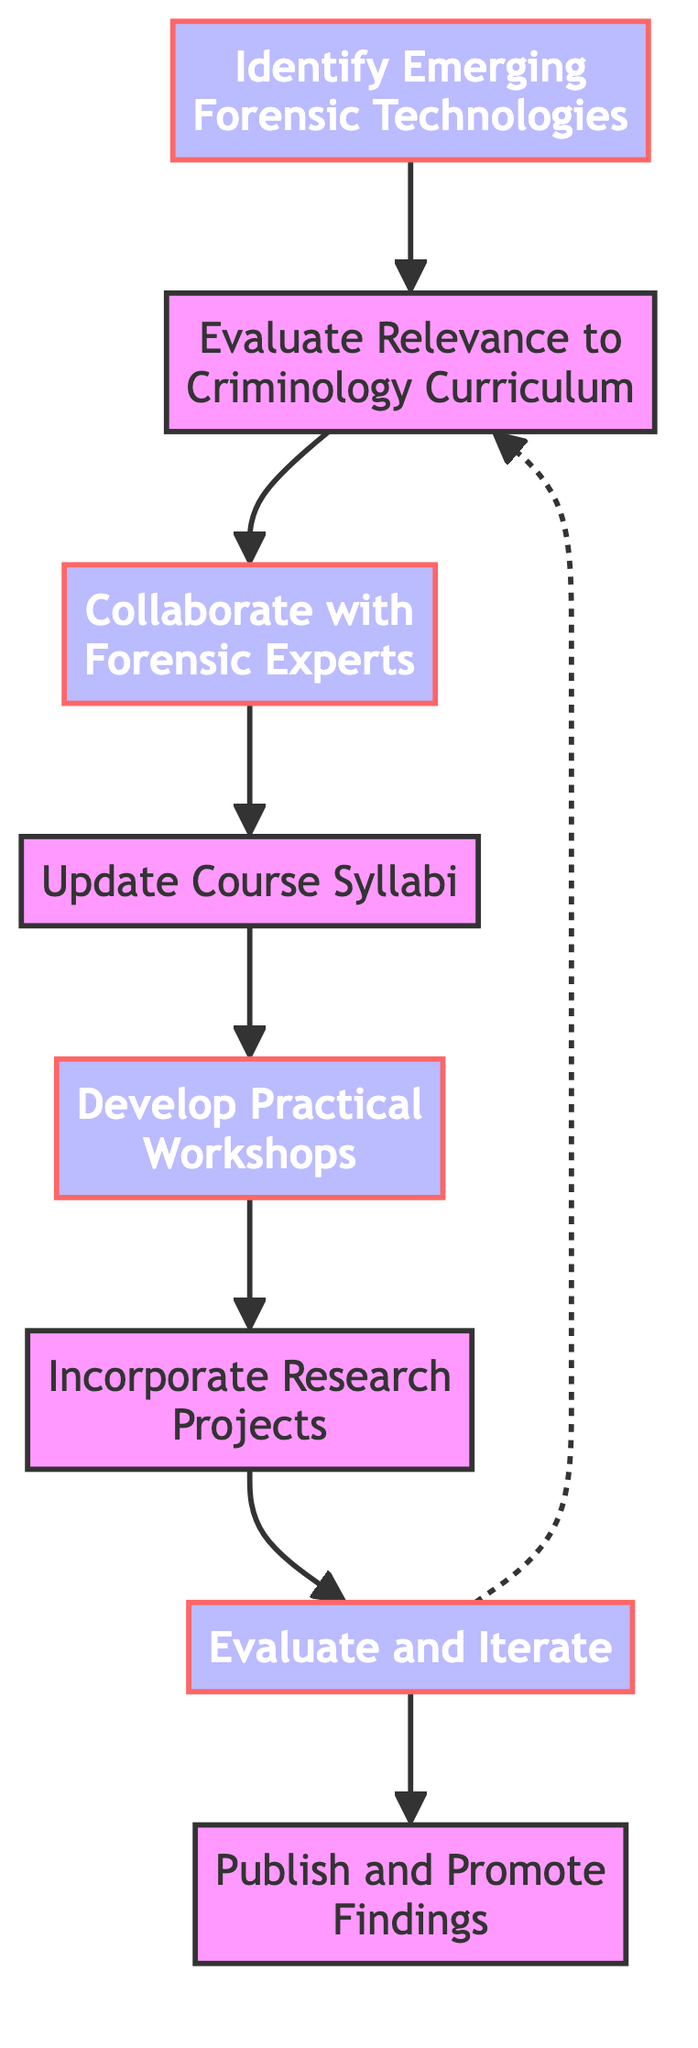What is the first step in the integration of new forensic technology? The first step shown in the diagram is "Identify Emerging Forensic Technologies," indicating that the process begins with surveying advancements in forensic science.
Answer: Identify Emerging Forensic Technologies How many main nodes are present in the diagram? The diagram features eight main nodes, representing distinct steps in the process of integrating new forensic technologies.
Answer: 8 Which step follows the "Evaluate Relevance to Criminology Curriculum"? The step that follows is "Collaborate with Forensic Experts," linking the assessment of relevance to forming partnerships with professionals in the field.
Answer: Collaborate with Forensic Experts What is the last step in the integration process? The final step outlined in the flow chart is "Publish and Promote Findings," where successful strategies and research results are shared with the academic community.
Answer: Publish and Promote Findings In which step are practical workshops developed? Practical workshops are developed in the step titled "Develop Practical Workshops," which comes after updating the course syllabi.
Answer: Develop Practical Workshops What is the relationship between "Evaluate and Iterate" and "Evaluate Relevance to Criminology Curriculum"? There is a dashed line indicating a feedback loop from "Evaluate and Iterate" back to "Evaluate Relevance to Criminology Curriculum," suggesting that feedback can lead to reassessing the relevance of technologies.
Answer: Feedback loop Which steps involve working directly with external experts? The steps "Collaborate with Forensic Experts" and "Incorporate Research Projects" both involve working with external experts, emphasizing collaboration in the curriculum.
Answer: Collaborate with Forensic Experts, Incorporate Research Projects What can be inferred about the role of feedback in this process? Feedback plays a critical role in the "Evaluate and Iterate" step, indicating that the integration of forensic technologies is subject to continuous assessment and improvement.
Answer: Continuous assessment and improvement 